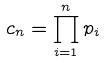Convert formula to latex. <formula><loc_0><loc_0><loc_500><loc_500>c _ { n } = \prod _ { i = 1 } ^ { n } p _ { i }</formula> 